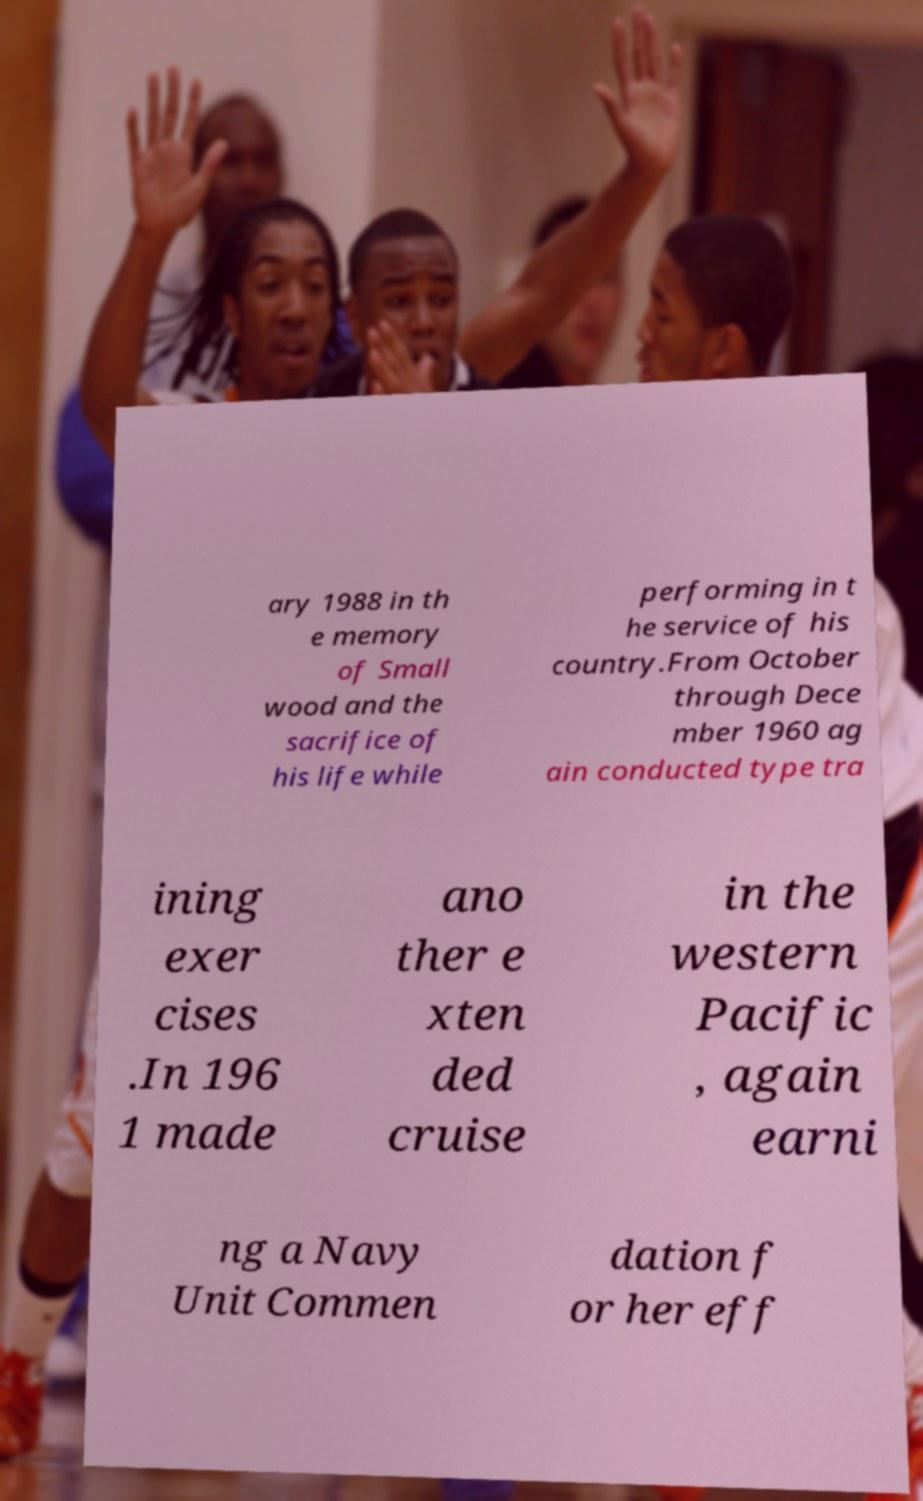I need the written content from this picture converted into text. Can you do that? ary 1988 in th e memory of Small wood and the sacrifice of his life while performing in t he service of his country.From October through Dece mber 1960 ag ain conducted type tra ining exer cises .In 196 1 made ano ther e xten ded cruise in the western Pacific , again earni ng a Navy Unit Commen dation f or her eff 